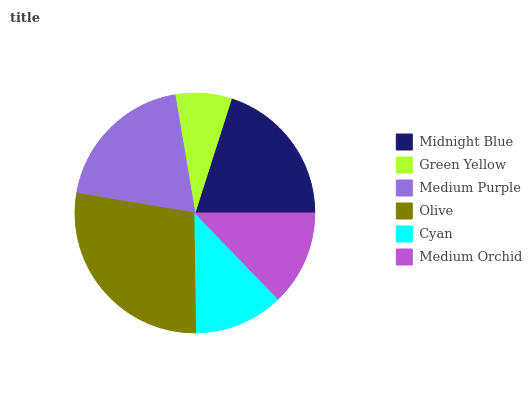Is Green Yellow the minimum?
Answer yes or no. Yes. Is Olive the maximum?
Answer yes or no. Yes. Is Medium Purple the minimum?
Answer yes or no. No. Is Medium Purple the maximum?
Answer yes or no. No. Is Medium Purple greater than Green Yellow?
Answer yes or no. Yes. Is Green Yellow less than Medium Purple?
Answer yes or no. Yes. Is Green Yellow greater than Medium Purple?
Answer yes or no. No. Is Medium Purple less than Green Yellow?
Answer yes or no. No. Is Medium Purple the high median?
Answer yes or no. Yes. Is Medium Orchid the low median?
Answer yes or no. Yes. Is Green Yellow the high median?
Answer yes or no. No. Is Medium Purple the low median?
Answer yes or no. No. 